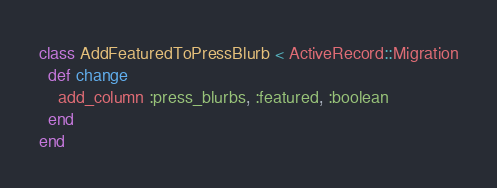Convert code to text. <code><loc_0><loc_0><loc_500><loc_500><_Ruby_>class AddFeaturedToPressBlurb < ActiveRecord::Migration
  def change
    add_column :press_blurbs, :featured, :boolean
  end
end
</code> 